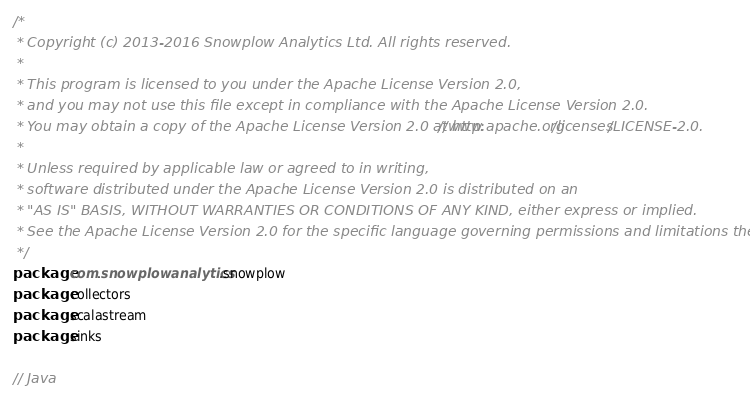Convert code to text. <code><loc_0><loc_0><loc_500><loc_500><_Scala_>/*
 * Copyright (c) 2013-2016 Snowplow Analytics Ltd. All rights reserved.
 *
 * This program is licensed to you under the Apache License Version 2.0,
 * and you may not use this file except in compliance with the Apache License Version 2.0.
 * You may obtain a copy of the Apache License Version 2.0 at http://www.apache.org/licenses/LICENSE-2.0.
 *
 * Unless required by applicable law or agreed to in writing,
 * software distributed under the Apache License Version 2.0 is distributed on an
 * "AS IS" BASIS, WITHOUT WARRANTIES OR CONDITIONS OF ANY KIND, either express or implied.
 * See the Apache License Version 2.0 for the specific language governing permissions and limitations there under.
 */
package com.snowplowanalytics.snowplow
package collectors
package scalastream
package sinks

// Java</code> 